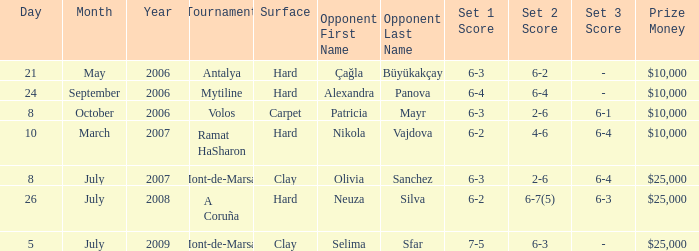What is the score of the match on September 24, 2006? 6-4 6-4. 